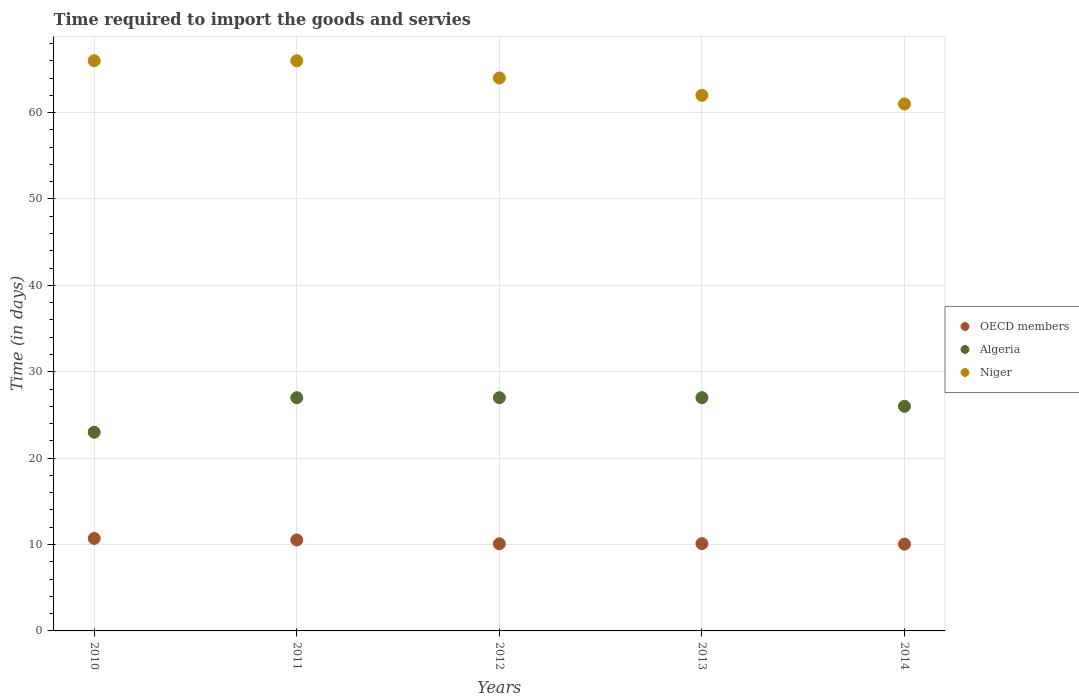What is the number of days required to import the goods and services in Niger in 2012?
Ensure brevity in your answer.  64. Across all years, what is the maximum number of days required to import the goods and services in OECD members?
Provide a short and direct response. 10.71. Across all years, what is the minimum number of days required to import the goods and services in Algeria?
Offer a terse response. 23. In which year was the number of days required to import the goods and services in Niger maximum?
Your answer should be very brief. 2010. What is the total number of days required to import the goods and services in OECD members in the graph?
Offer a very short reply. 51.48. What is the difference between the number of days required to import the goods and services in OECD members in 2013 and the number of days required to import the goods and services in Algeria in 2010?
Make the answer very short. -12.89. What is the average number of days required to import the goods and services in Niger per year?
Provide a short and direct response. 63.8. In the year 2013, what is the difference between the number of days required to import the goods and services in Niger and number of days required to import the goods and services in OECD members?
Give a very brief answer. 51.89. What is the ratio of the number of days required to import the goods and services in Algeria in 2011 to that in 2013?
Offer a very short reply. 1. Is the difference between the number of days required to import the goods and services in Niger in 2010 and 2014 greater than the difference between the number of days required to import the goods and services in OECD members in 2010 and 2014?
Your answer should be very brief. Yes. What is the difference between the highest and the lowest number of days required to import the goods and services in Algeria?
Offer a terse response. 4. Is the sum of the number of days required to import the goods and services in Algeria in 2010 and 2013 greater than the maximum number of days required to import the goods and services in Niger across all years?
Make the answer very short. No. Is the number of days required to import the goods and services in Algeria strictly less than the number of days required to import the goods and services in Niger over the years?
Keep it short and to the point. Yes. Does the graph contain any zero values?
Provide a short and direct response. No. How many legend labels are there?
Ensure brevity in your answer.  3. How are the legend labels stacked?
Provide a short and direct response. Vertical. What is the title of the graph?
Give a very brief answer. Time required to import the goods and servies. What is the label or title of the X-axis?
Provide a short and direct response. Years. What is the label or title of the Y-axis?
Provide a short and direct response. Time (in days). What is the Time (in days) of OECD members in 2010?
Offer a very short reply. 10.71. What is the Time (in days) in Niger in 2010?
Your answer should be compact. 66. What is the Time (in days) of OECD members in 2011?
Provide a short and direct response. 10.53. What is the Time (in days) of Algeria in 2011?
Ensure brevity in your answer.  27. What is the Time (in days) in Niger in 2011?
Make the answer very short. 66. What is the Time (in days) of OECD members in 2012?
Your answer should be very brief. 10.09. What is the Time (in days) of OECD members in 2013?
Give a very brief answer. 10.11. What is the Time (in days) of Niger in 2013?
Ensure brevity in your answer.  62. What is the Time (in days) in OECD members in 2014?
Make the answer very short. 10.05. Across all years, what is the maximum Time (in days) in OECD members?
Provide a short and direct response. 10.71. Across all years, what is the maximum Time (in days) of Algeria?
Ensure brevity in your answer.  27. Across all years, what is the maximum Time (in days) of Niger?
Provide a short and direct response. 66. Across all years, what is the minimum Time (in days) of OECD members?
Provide a short and direct response. 10.05. Across all years, what is the minimum Time (in days) in Algeria?
Your answer should be compact. 23. What is the total Time (in days) in OECD members in the graph?
Your answer should be very brief. 51.48. What is the total Time (in days) in Algeria in the graph?
Keep it short and to the point. 130. What is the total Time (in days) of Niger in the graph?
Offer a terse response. 319. What is the difference between the Time (in days) in OECD members in 2010 and that in 2011?
Keep it short and to the point. 0.18. What is the difference between the Time (in days) in Algeria in 2010 and that in 2011?
Keep it short and to the point. -4. What is the difference between the Time (in days) in OECD members in 2010 and that in 2012?
Your answer should be very brief. 0.62. What is the difference between the Time (in days) of OECD members in 2010 and that in 2013?
Your answer should be compact. 0.6. What is the difference between the Time (in days) in Algeria in 2010 and that in 2013?
Provide a succinct answer. -4. What is the difference between the Time (in days) of OECD members in 2010 and that in 2014?
Offer a very short reply. 0.66. What is the difference between the Time (in days) in Algeria in 2010 and that in 2014?
Offer a terse response. -3. What is the difference between the Time (in days) of OECD members in 2011 and that in 2012?
Provide a succinct answer. 0.44. What is the difference between the Time (in days) in OECD members in 2011 and that in 2013?
Your answer should be compact. 0.42. What is the difference between the Time (in days) of Algeria in 2011 and that in 2013?
Give a very brief answer. 0. What is the difference between the Time (in days) in Niger in 2011 and that in 2013?
Make the answer very short. 4. What is the difference between the Time (in days) in OECD members in 2011 and that in 2014?
Your response must be concise. 0.48. What is the difference between the Time (in days) of Algeria in 2011 and that in 2014?
Offer a very short reply. 1. What is the difference between the Time (in days) of OECD members in 2012 and that in 2013?
Your answer should be compact. -0.02. What is the difference between the Time (in days) in Niger in 2012 and that in 2013?
Your answer should be compact. 2. What is the difference between the Time (in days) in OECD members in 2012 and that in 2014?
Provide a succinct answer. 0.04. What is the difference between the Time (in days) of OECD members in 2013 and that in 2014?
Keep it short and to the point. 0.06. What is the difference between the Time (in days) in Algeria in 2013 and that in 2014?
Your answer should be compact. 1. What is the difference between the Time (in days) in Niger in 2013 and that in 2014?
Your answer should be compact. 1. What is the difference between the Time (in days) in OECD members in 2010 and the Time (in days) in Algeria in 2011?
Provide a short and direct response. -16.29. What is the difference between the Time (in days) of OECD members in 2010 and the Time (in days) of Niger in 2011?
Ensure brevity in your answer.  -55.29. What is the difference between the Time (in days) in Algeria in 2010 and the Time (in days) in Niger in 2011?
Offer a very short reply. -43. What is the difference between the Time (in days) in OECD members in 2010 and the Time (in days) in Algeria in 2012?
Offer a terse response. -16.29. What is the difference between the Time (in days) in OECD members in 2010 and the Time (in days) in Niger in 2012?
Make the answer very short. -53.29. What is the difference between the Time (in days) of Algeria in 2010 and the Time (in days) of Niger in 2012?
Your answer should be compact. -41. What is the difference between the Time (in days) in OECD members in 2010 and the Time (in days) in Algeria in 2013?
Your response must be concise. -16.29. What is the difference between the Time (in days) of OECD members in 2010 and the Time (in days) of Niger in 2013?
Offer a terse response. -51.29. What is the difference between the Time (in days) in Algeria in 2010 and the Time (in days) in Niger in 2013?
Provide a short and direct response. -39. What is the difference between the Time (in days) in OECD members in 2010 and the Time (in days) in Algeria in 2014?
Your answer should be compact. -15.29. What is the difference between the Time (in days) of OECD members in 2010 and the Time (in days) of Niger in 2014?
Your response must be concise. -50.29. What is the difference between the Time (in days) of Algeria in 2010 and the Time (in days) of Niger in 2014?
Give a very brief answer. -38. What is the difference between the Time (in days) in OECD members in 2011 and the Time (in days) in Algeria in 2012?
Keep it short and to the point. -16.47. What is the difference between the Time (in days) of OECD members in 2011 and the Time (in days) of Niger in 2012?
Provide a short and direct response. -53.47. What is the difference between the Time (in days) of Algeria in 2011 and the Time (in days) of Niger in 2012?
Your answer should be very brief. -37. What is the difference between the Time (in days) of OECD members in 2011 and the Time (in days) of Algeria in 2013?
Your answer should be compact. -16.47. What is the difference between the Time (in days) of OECD members in 2011 and the Time (in days) of Niger in 2013?
Your answer should be compact. -51.47. What is the difference between the Time (in days) in Algeria in 2011 and the Time (in days) in Niger in 2013?
Give a very brief answer. -35. What is the difference between the Time (in days) of OECD members in 2011 and the Time (in days) of Algeria in 2014?
Offer a terse response. -15.47. What is the difference between the Time (in days) of OECD members in 2011 and the Time (in days) of Niger in 2014?
Provide a short and direct response. -50.47. What is the difference between the Time (in days) in Algeria in 2011 and the Time (in days) in Niger in 2014?
Keep it short and to the point. -34. What is the difference between the Time (in days) of OECD members in 2012 and the Time (in days) of Algeria in 2013?
Your response must be concise. -16.91. What is the difference between the Time (in days) of OECD members in 2012 and the Time (in days) of Niger in 2013?
Keep it short and to the point. -51.91. What is the difference between the Time (in days) in Algeria in 2012 and the Time (in days) in Niger in 2013?
Keep it short and to the point. -35. What is the difference between the Time (in days) in OECD members in 2012 and the Time (in days) in Algeria in 2014?
Ensure brevity in your answer.  -15.91. What is the difference between the Time (in days) of OECD members in 2012 and the Time (in days) of Niger in 2014?
Your answer should be very brief. -50.91. What is the difference between the Time (in days) in Algeria in 2012 and the Time (in days) in Niger in 2014?
Ensure brevity in your answer.  -34. What is the difference between the Time (in days) in OECD members in 2013 and the Time (in days) in Algeria in 2014?
Ensure brevity in your answer.  -15.89. What is the difference between the Time (in days) in OECD members in 2013 and the Time (in days) in Niger in 2014?
Your response must be concise. -50.89. What is the difference between the Time (in days) in Algeria in 2013 and the Time (in days) in Niger in 2014?
Give a very brief answer. -34. What is the average Time (in days) of OECD members per year?
Offer a terse response. 10.3. What is the average Time (in days) of Niger per year?
Make the answer very short. 63.8. In the year 2010, what is the difference between the Time (in days) of OECD members and Time (in days) of Algeria?
Offer a terse response. -12.29. In the year 2010, what is the difference between the Time (in days) in OECD members and Time (in days) in Niger?
Your response must be concise. -55.29. In the year 2010, what is the difference between the Time (in days) in Algeria and Time (in days) in Niger?
Provide a short and direct response. -43. In the year 2011, what is the difference between the Time (in days) in OECD members and Time (in days) in Algeria?
Provide a short and direct response. -16.47. In the year 2011, what is the difference between the Time (in days) in OECD members and Time (in days) in Niger?
Ensure brevity in your answer.  -55.47. In the year 2011, what is the difference between the Time (in days) of Algeria and Time (in days) of Niger?
Ensure brevity in your answer.  -39. In the year 2012, what is the difference between the Time (in days) in OECD members and Time (in days) in Algeria?
Your answer should be very brief. -16.91. In the year 2012, what is the difference between the Time (in days) in OECD members and Time (in days) in Niger?
Give a very brief answer. -53.91. In the year 2012, what is the difference between the Time (in days) of Algeria and Time (in days) of Niger?
Your answer should be very brief. -37. In the year 2013, what is the difference between the Time (in days) in OECD members and Time (in days) in Algeria?
Give a very brief answer. -16.89. In the year 2013, what is the difference between the Time (in days) in OECD members and Time (in days) in Niger?
Make the answer very short. -51.89. In the year 2013, what is the difference between the Time (in days) in Algeria and Time (in days) in Niger?
Your answer should be very brief. -35. In the year 2014, what is the difference between the Time (in days) of OECD members and Time (in days) of Algeria?
Provide a short and direct response. -15.95. In the year 2014, what is the difference between the Time (in days) of OECD members and Time (in days) of Niger?
Ensure brevity in your answer.  -50.95. In the year 2014, what is the difference between the Time (in days) in Algeria and Time (in days) in Niger?
Provide a short and direct response. -35. What is the ratio of the Time (in days) of OECD members in 2010 to that in 2011?
Ensure brevity in your answer.  1.02. What is the ratio of the Time (in days) of Algeria in 2010 to that in 2011?
Give a very brief answer. 0.85. What is the ratio of the Time (in days) of Niger in 2010 to that in 2011?
Provide a short and direct response. 1. What is the ratio of the Time (in days) of OECD members in 2010 to that in 2012?
Keep it short and to the point. 1.06. What is the ratio of the Time (in days) of Algeria in 2010 to that in 2012?
Offer a very short reply. 0.85. What is the ratio of the Time (in days) in Niger in 2010 to that in 2012?
Ensure brevity in your answer.  1.03. What is the ratio of the Time (in days) of OECD members in 2010 to that in 2013?
Offer a terse response. 1.06. What is the ratio of the Time (in days) in Algeria in 2010 to that in 2013?
Make the answer very short. 0.85. What is the ratio of the Time (in days) of Niger in 2010 to that in 2013?
Offer a terse response. 1.06. What is the ratio of the Time (in days) of OECD members in 2010 to that in 2014?
Provide a succinct answer. 1.07. What is the ratio of the Time (in days) of Algeria in 2010 to that in 2014?
Keep it short and to the point. 0.88. What is the ratio of the Time (in days) of Niger in 2010 to that in 2014?
Your answer should be compact. 1.08. What is the ratio of the Time (in days) of OECD members in 2011 to that in 2012?
Provide a short and direct response. 1.04. What is the ratio of the Time (in days) in Niger in 2011 to that in 2012?
Ensure brevity in your answer.  1.03. What is the ratio of the Time (in days) in OECD members in 2011 to that in 2013?
Provide a short and direct response. 1.04. What is the ratio of the Time (in days) of Algeria in 2011 to that in 2013?
Your answer should be compact. 1. What is the ratio of the Time (in days) of Niger in 2011 to that in 2013?
Provide a succinct answer. 1.06. What is the ratio of the Time (in days) of OECD members in 2011 to that in 2014?
Your answer should be compact. 1.05. What is the ratio of the Time (in days) in Algeria in 2011 to that in 2014?
Provide a succinct answer. 1.04. What is the ratio of the Time (in days) in Niger in 2011 to that in 2014?
Keep it short and to the point. 1.08. What is the ratio of the Time (in days) in OECD members in 2012 to that in 2013?
Your answer should be compact. 1. What is the ratio of the Time (in days) of Niger in 2012 to that in 2013?
Offer a very short reply. 1.03. What is the ratio of the Time (in days) of Niger in 2012 to that in 2014?
Make the answer very short. 1.05. What is the ratio of the Time (in days) of OECD members in 2013 to that in 2014?
Provide a short and direct response. 1.01. What is the ratio of the Time (in days) in Algeria in 2013 to that in 2014?
Give a very brief answer. 1.04. What is the ratio of the Time (in days) in Niger in 2013 to that in 2014?
Keep it short and to the point. 1.02. What is the difference between the highest and the second highest Time (in days) of OECD members?
Your answer should be very brief. 0.18. What is the difference between the highest and the second highest Time (in days) in Algeria?
Provide a succinct answer. 0. What is the difference between the highest and the second highest Time (in days) in Niger?
Provide a succinct answer. 0. What is the difference between the highest and the lowest Time (in days) in OECD members?
Your answer should be very brief. 0.66. What is the difference between the highest and the lowest Time (in days) in Algeria?
Ensure brevity in your answer.  4. 